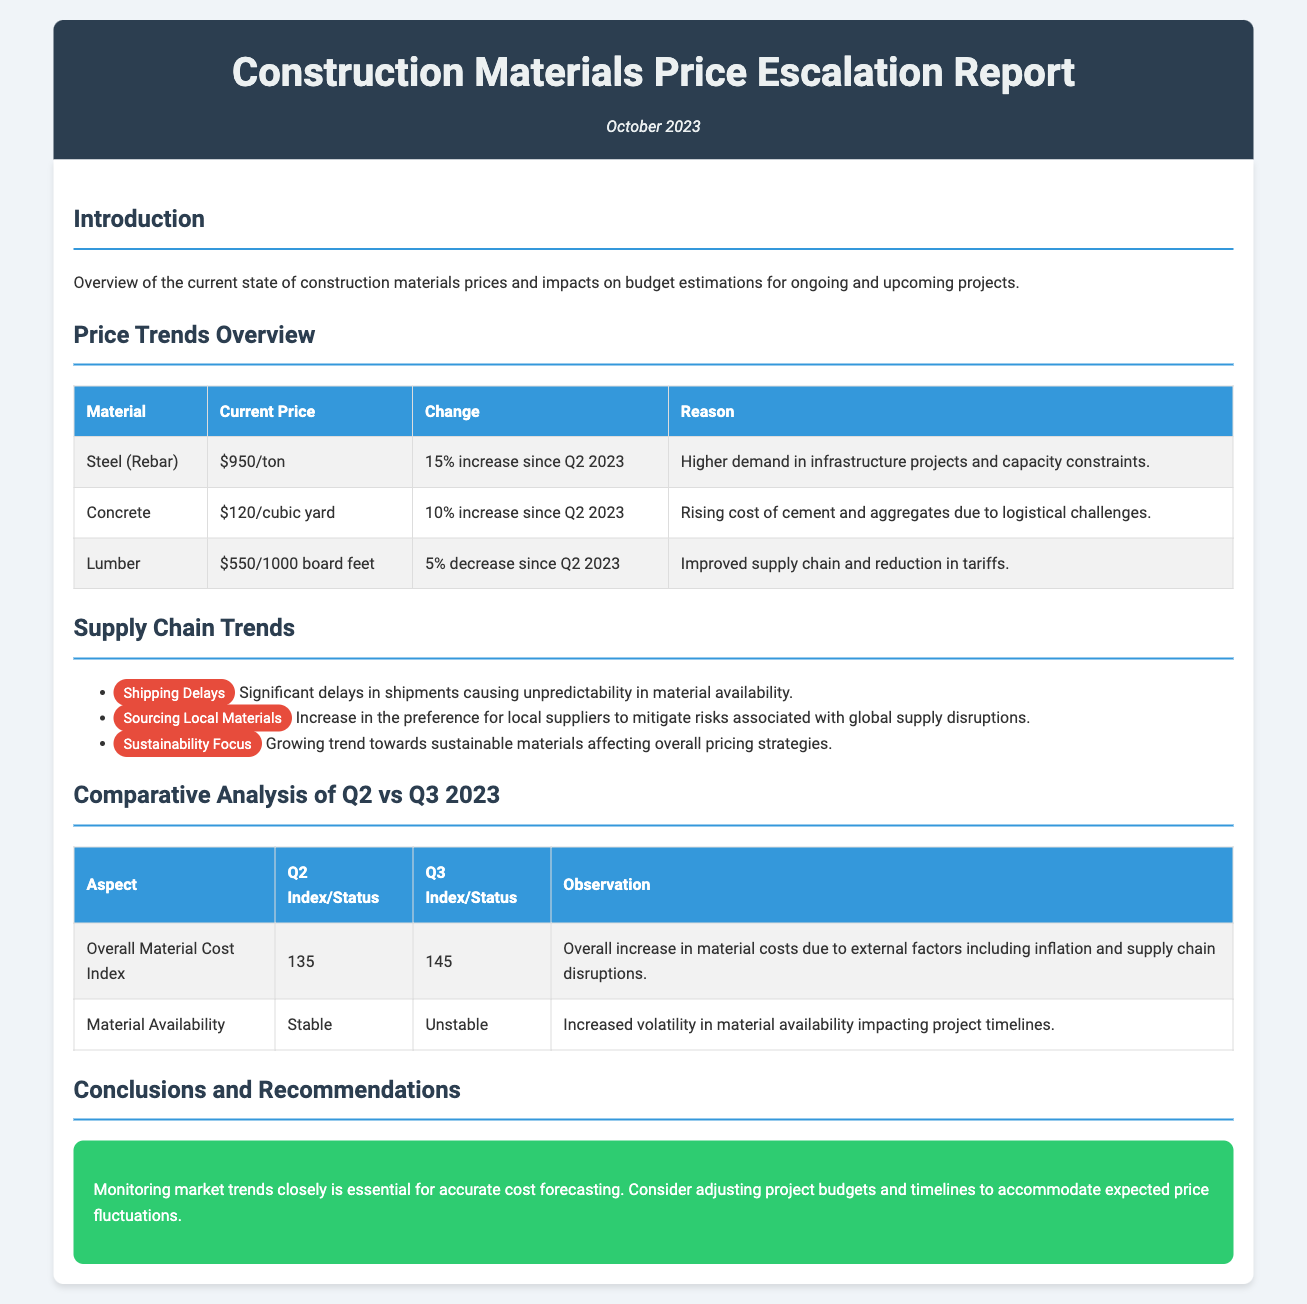What is the current price of steel (rebar)? The current price of steel (rebar) is listed in the "Price Trends Overview" section of the document.
Answer: $950/ton What was the percentage change in concrete prices from Q2 to Q3 2023? The percentage change in concrete prices can be found in the "Price Trends Overview" section under the concrete entry.
Answer: 10% increase What is affecting the price hike of steel? The reasons for the price increase of steel are stated in the document under the steel entry.
Answer: Higher demand in infrastructure projects and capacity constraints What is the Overall Material Cost Index for Q3 2023? The Overall Material Cost Index for Q3 2023 is presented in the "Comparative Analysis of Q2 vs Q3 2023" section.
Answer: 145 What trend is noted for sourcing materials? The trends regarding materials sourcing are listed in the "Supply Chain Trends" section.
Answer: Increase in the preference for local suppliers What does "unstable" refer to in the context of material availability? "Unstable" refers to the comparison of material availability between Q2 and Q3 2023, as mentioned in the comparative analysis.
Answer: Material Availability What is recommended for managing expected price fluctuations? Recommendations regarding managing price fluctuations are found in the "Conclusions and Recommendations" section of the document.
Answer: Adjusting project budgets and timelines What was the current price of lumber in Q3 2023? The current price of lumber is stated in the "Price Trends Overview" section.
Answer: $550/1000 board feet What is the main factor for the increase in material costs? The main factor for the increase in material costs is provided in the "Comparative Analysis of Q2 vs Q3 2023" table.
Answer: External factors including inflation and supply chain disruptions 